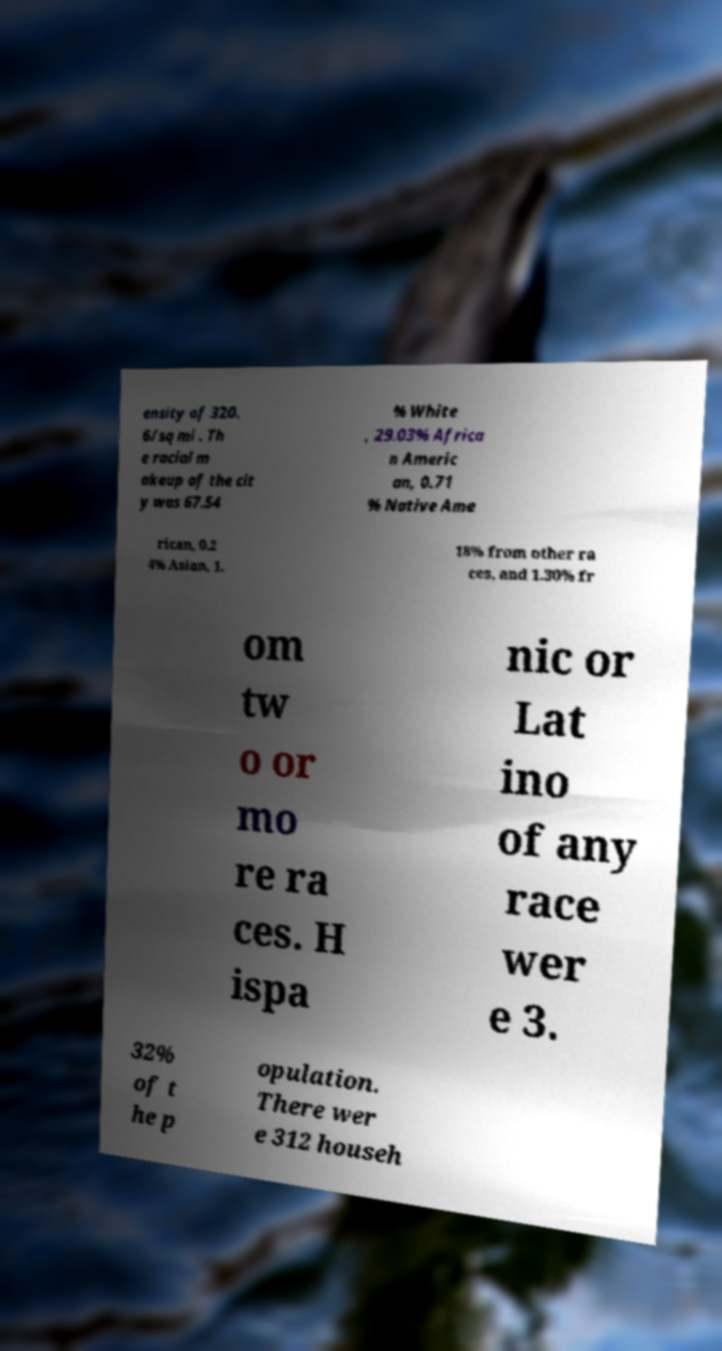Can you accurately transcribe the text from the provided image for me? ensity of 320. 6/sq mi . Th e racial m akeup of the cit y was 67.54 % White , 29.03% Africa n Americ an, 0.71 % Native Ame rican, 0.2 4% Asian, 1. 18% from other ra ces, and 1.30% fr om tw o or mo re ra ces. H ispa nic or Lat ino of any race wer e 3. 32% of t he p opulation. There wer e 312 househ 